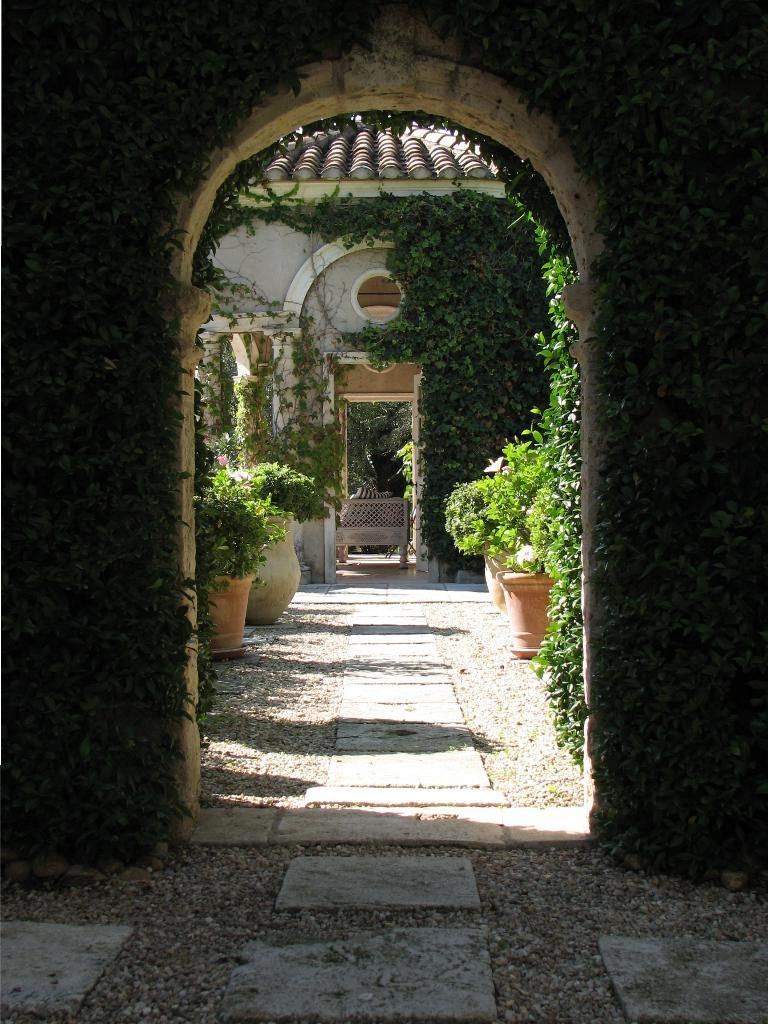What structure is the main focus of the image? There is an arch in the image. How are the plants related to the arch? The arch is covered with plants. What can be seen behind the arch? There is a house and a table behind the arch. What type of plants are visible behind the arch? There are houseplants visible behind the arch. Is there an apple stuck in the quicksand near the arch in the image? There is no quicksand or apple present in the image. What is the cause of death for the person standing near the arch in the image? There is no person or indication of death in the image. 